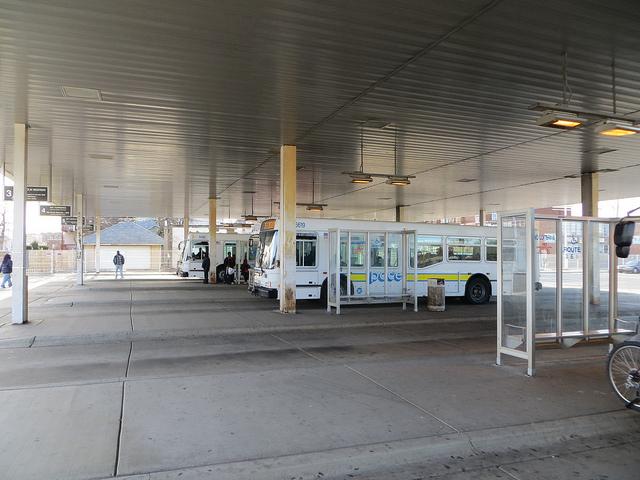What kind of vehicles are these?
Concise answer only. Buses. What are the waiting areas made of?
Answer briefly. Glass. Does this appear to be a bus terminal?
Short answer required. Yes. Why does the terminal  have little  foot traffic?
Answer briefly. Empty. Is it raining?
Be succinct. No. 